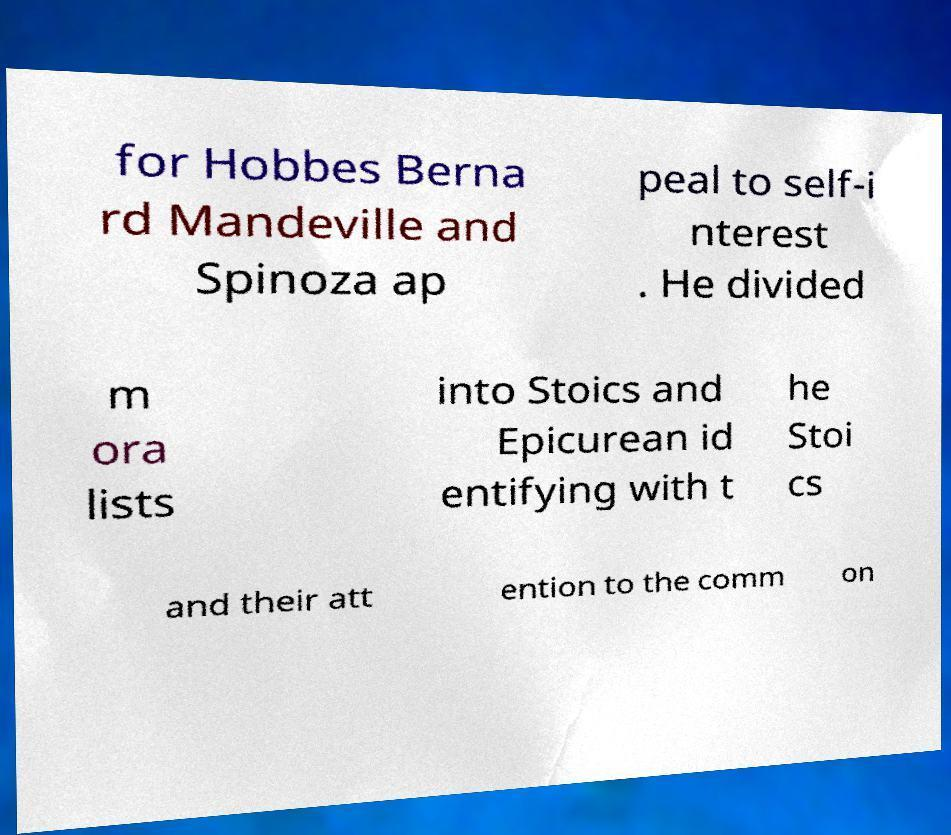There's text embedded in this image that I need extracted. Can you transcribe it verbatim? for Hobbes Berna rd Mandeville and Spinoza ap peal to self-i nterest . He divided m ora lists into Stoics and Epicurean id entifying with t he Stoi cs and their att ention to the comm on 